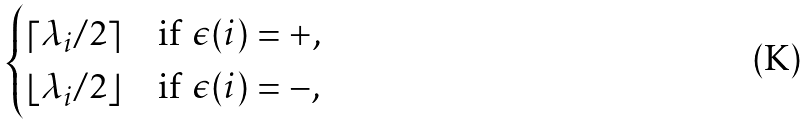<formula> <loc_0><loc_0><loc_500><loc_500>\begin{cases} \lceil \lambda _ { i } / 2 \rceil & \text {if $\epsilon(i) = +$,} \\ \lfloor \lambda _ { i } / 2 \rfloor & \text {if $\epsilon(i) = -$,} \end{cases}</formula> 